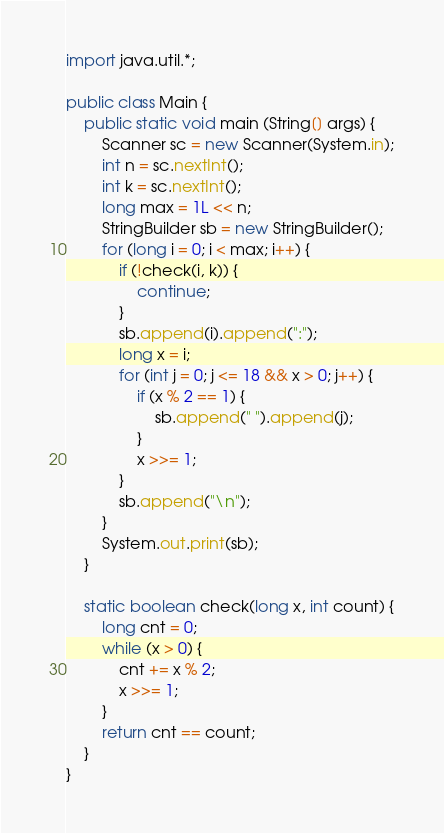<code> <loc_0><loc_0><loc_500><loc_500><_Java_>import java.util.*;

public class Main {
	public static void main (String[] args) {
		Scanner sc = new Scanner(System.in);
		int n = sc.nextInt();
		int k = sc.nextInt();
		long max = 1L << n;
		StringBuilder sb = new StringBuilder();
		for (long i = 0; i < max; i++) {
		    if (!check(i, k)) {
		        continue;
		    }
		    sb.append(i).append(":");
		    long x = i;
		    for (int j = 0; j <= 18 && x > 0; j++) {
		        if (x % 2 == 1) {
		            sb.append(" ").append(j);
		        }
		        x >>= 1;
		    }
		    sb.append("\n");
		}
		System.out.print(sb);
	}
	
	static boolean check(long x, int count) {
	    long cnt = 0;
	    while (x > 0) {
	        cnt += x % 2;
	        x >>= 1;
	    }
	    return cnt == count;
	}
}

</code> 